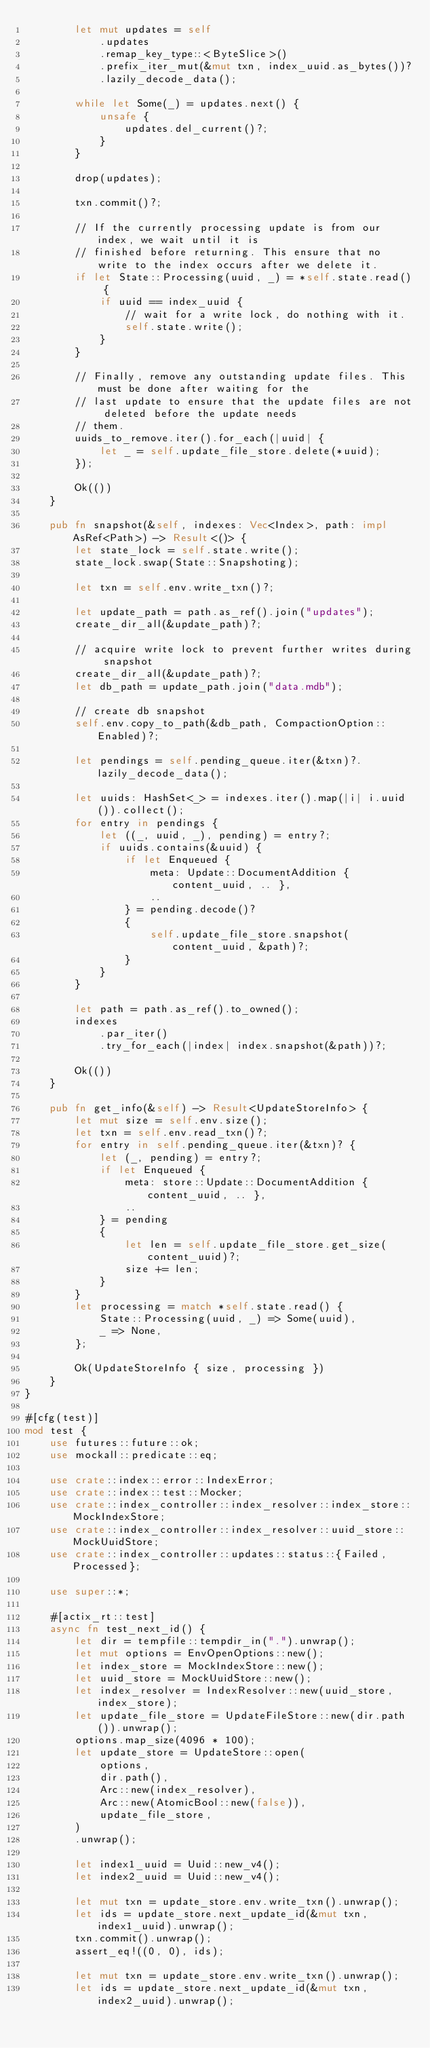<code> <loc_0><loc_0><loc_500><loc_500><_Rust_>        let mut updates = self
            .updates
            .remap_key_type::<ByteSlice>()
            .prefix_iter_mut(&mut txn, index_uuid.as_bytes())?
            .lazily_decode_data();

        while let Some(_) = updates.next() {
            unsafe {
                updates.del_current()?;
            }
        }

        drop(updates);

        txn.commit()?;

        // If the currently processing update is from our index, we wait until it is
        // finished before returning. This ensure that no write to the index occurs after we delete it.
        if let State::Processing(uuid, _) = *self.state.read() {
            if uuid == index_uuid {
                // wait for a write lock, do nothing with it.
                self.state.write();
            }
        }

        // Finally, remove any outstanding update files. This must be done after waiting for the
        // last update to ensure that the update files are not deleted before the update needs
        // them.
        uuids_to_remove.iter().for_each(|uuid| {
            let _ = self.update_file_store.delete(*uuid);
        });

        Ok(())
    }

    pub fn snapshot(&self, indexes: Vec<Index>, path: impl AsRef<Path>) -> Result<()> {
        let state_lock = self.state.write();
        state_lock.swap(State::Snapshoting);

        let txn = self.env.write_txn()?;

        let update_path = path.as_ref().join("updates");
        create_dir_all(&update_path)?;

        // acquire write lock to prevent further writes during snapshot
        create_dir_all(&update_path)?;
        let db_path = update_path.join("data.mdb");

        // create db snapshot
        self.env.copy_to_path(&db_path, CompactionOption::Enabled)?;

        let pendings = self.pending_queue.iter(&txn)?.lazily_decode_data();

        let uuids: HashSet<_> = indexes.iter().map(|i| i.uuid()).collect();
        for entry in pendings {
            let ((_, uuid, _), pending) = entry?;
            if uuids.contains(&uuid) {
                if let Enqueued {
                    meta: Update::DocumentAddition { content_uuid, .. },
                    ..
                } = pending.decode()?
                {
                    self.update_file_store.snapshot(content_uuid, &path)?;
                }
            }
        }

        let path = path.as_ref().to_owned();
        indexes
            .par_iter()
            .try_for_each(|index| index.snapshot(&path))?;

        Ok(())
    }

    pub fn get_info(&self) -> Result<UpdateStoreInfo> {
        let mut size = self.env.size();
        let txn = self.env.read_txn()?;
        for entry in self.pending_queue.iter(&txn)? {
            let (_, pending) = entry?;
            if let Enqueued {
                meta: store::Update::DocumentAddition { content_uuid, .. },
                ..
            } = pending
            {
                let len = self.update_file_store.get_size(content_uuid)?;
                size += len;
            }
        }
        let processing = match *self.state.read() {
            State::Processing(uuid, _) => Some(uuid),
            _ => None,
        };

        Ok(UpdateStoreInfo { size, processing })
    }
}

#[cfg(test)]
mod test {
    use futures::future::ok;
    use mockall::predicate::eq;

    use crate::index::error::IndexError;
    use crate::index::test::Mocker;
    use crate::index_controller::index_resolver::index_store::MockIndexStore;
    use crate::index_controller::index_resolver::uuid_store::MockUuidStore;
    use crate::index_controller::updates::status::{Failed, Processed};

    use super::*;

    #[actix_rt::test]
    async fn test_next_id() {
        let dir = tempfile::tempdir_in(".").unwrap();
        let mut options = EnvOpenOptions::new();
        let index_store = MockIndexStore::new();
        let uuid_store = MockUuidStore::new();
        let index_resolver = IndexResolver::new(uuid_store, index_store);
        let update_file_store = UpdateFileStore::new(dir.path()).unwrap();
        options.map_size(4096 * 100);
        let update_store = UpdateStore::open(
            options,
            dir.path(),
            Arc::new(index_resolver),
            Arc::new(AtomicBool::new(false)),
            update_file_store,
        )
        .unwrap();

        let index1_uuid = Uuid::new_v4();
        let index2_uuid = Uuid::new_v4();

        let mut txn = update_store.env.write_txn().unwrap();
        let ids = update_store.next_update_id(&mut txn, index1_uuid).unwrap();
        txn.commit().unwrap();
        assert_eq!((0, 0), ids);

        let mut txn = update_store.env.write_txn().unwrap();
        let ids = update_store.next_update_id(&mut txn, index2_uuid).unwrap();</code> 